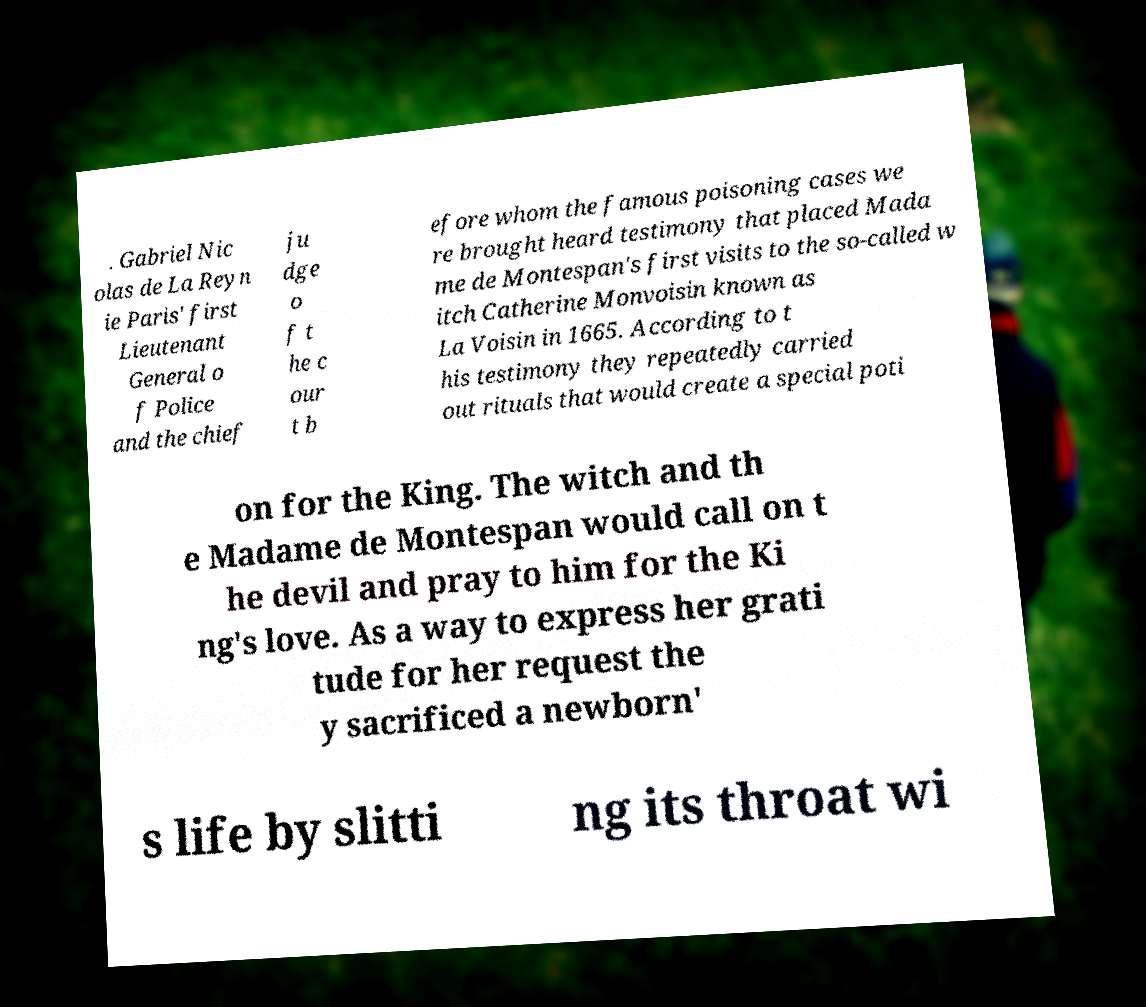Could you extract and type out the text from this image? . Gabriel Nic olas de La Reyn ie Paris' first Lieutenant General o f Police and the chief ju dge o f t he c our t b efore whom the famous poisoning cases we re brought heard testimony that placed Mada me de Montespan's first visits to the so-called w itch Catherine Monvoisin known as La Voisin in 1665. According to t his testimony they repeatedly carried out rituals that would create a special poti on for the King. The witch and th e Madame de Montespan would call on t he devil and pray to him for the Ki ng's love. As a way to express her grati tude for her request the y sacrificed a newborn' s life by slitti ng its throat wi 